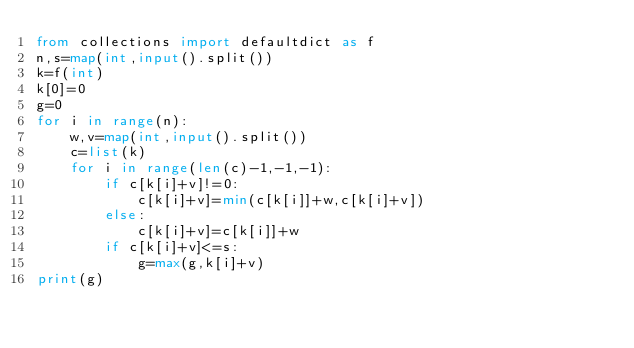<code> <loc_0><loc_0><loc_500><loc_500><_Python_>from collections import defaultdict as f
n,s=map(int,input().split())
k=f(int)
k[0]=0
g=0
for i in range(n):
    w,v=map(int,input().split())
    c=list(k)
    for i in range(len(c)-1,-1,-1):
        if c[k[i]+v]!=0:
            c[k[i]+v]=min(c[k[i]]+w,c[k[i]+v])
        else:
            c[k[i]+v]=c[k[i]]+w
        if c[k[i]+v]<=s:
            g=max(g,k[i]+v)
print(g)              </code> 